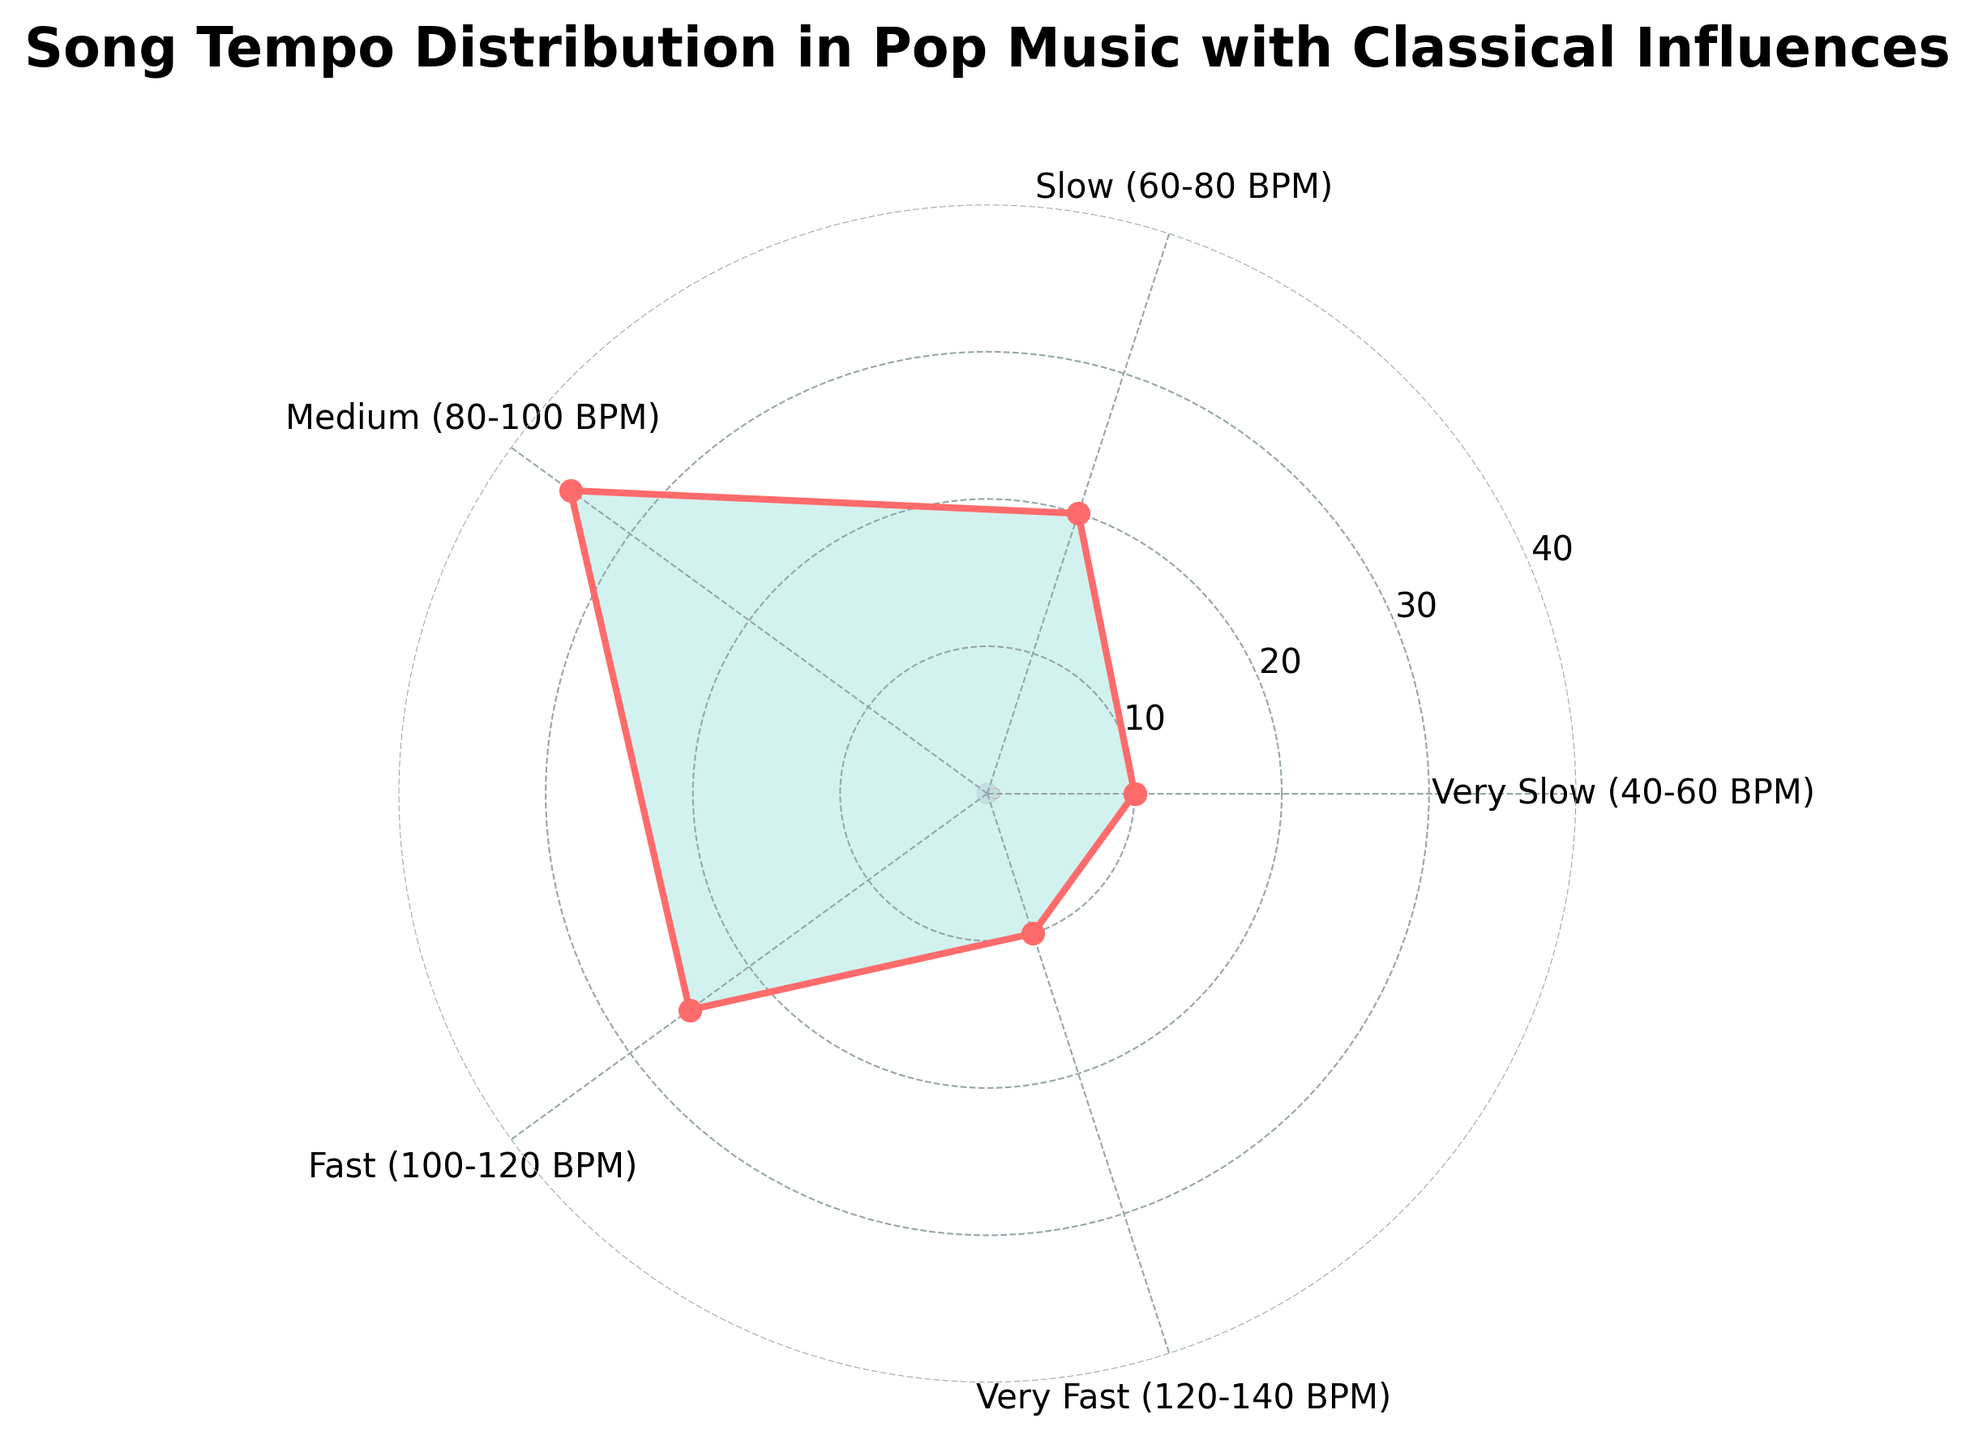What's the title of the chart? The title is typically displayed at the top of the chart, making it easily visible.
Answer: Song Tempo Distribution in Pop Music with Classical Influences How many tempo ranges are represented in the chart? To find this, list out all the tempo ranges from the labels on the chart.
Answer: 5 Which tempo range has the highest percentage of songs? Observe the data points and identify the one with the highest value.
Answer: Medium (80-100 BPM) How much higher is the percentage of Medium tempo songs compared to Very Slow tempo songs? Subtract the percentage of Very Slow tempo songs from that of Medium tempo songs: 35% - 10% = 25%
Answer: 25% What is the total percentage of songs with tempo ranges between 60 BPM to 120 BPM? Add the percentages for the tempo ranges between 60-80 BPM (Slow), 80-100 BPM (Medium), and 100-120 BPM (Fast): 20% + 35% + 25% = 80%
Answer: 80% Which tempo range has the lowest percentage of songs? Examine the data points and identify the lowest value.
Answer: Very Slow (40-60 BPM) Are there any tempo ranges with an equal percentage of songs? Compare the percentages for each tempo range. If any two are the same, identify them. In this case, Very Slow and Very Fast both have 10%.
Answer: Yes, Very Slow (40-60 BPM) and Very Fast (120-140 BPM) What is the combined percentage of songs in the Very Slow and Very Fast tempo ranges? Add the percentages for Very Slow and Very Fast tempo ranges: 10% + 10% = 20%
Answer: 20% How does the percentage of Slow tempo songs compare to Fast tempo songs? Compare their percentages. Slow tempo songs are at 20%, while Fast tempo songs are at 25%.
Answer: Fast is higher by 5% Which color represents the data plotted on the polar axis? Identify the color used for the data points and connecting lines.
Answer: #FF6B6B 